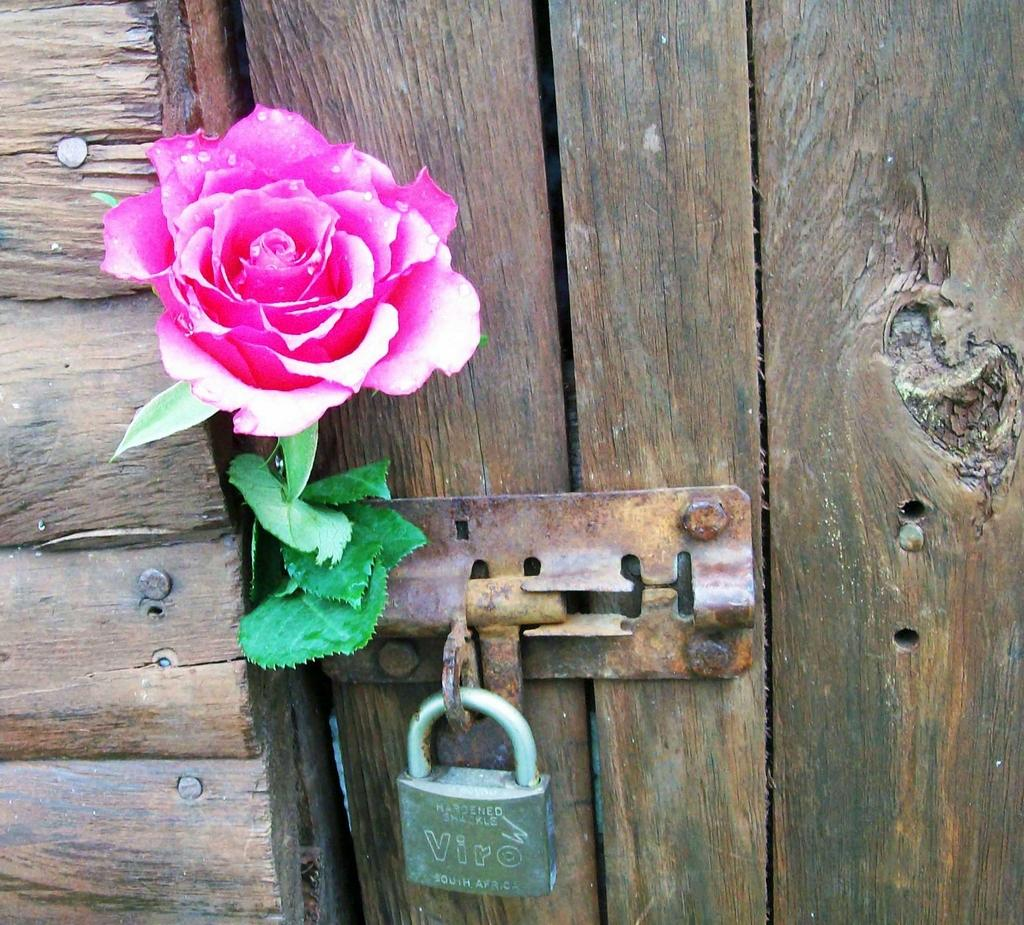What type of door is visible in the image? There is a wooden door in the image. What is the status of the door in the image? The door is locked. Are there any other objects or elements in the image besides the door? Yes, there is a pink flower in the image. How many bags of popcorn are visible in the image? There are no bags of popcorn present in the image. What type of quiver is shown in the image? There is no quiver present in the image. 